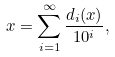Convert formula to latex. <formula><loc_0><loc_0><loc_500><loc_500>x = \sum _ { i = 1 } ^ { \infty } \frac { d _ { i } ( x ) } { 1 0 ^ { i } } ,</formula> 